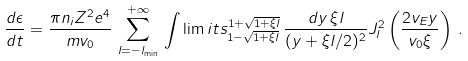Convert formula to latex. <formula><loc_0><loc_0><loc_500><loc_500>\frac { d \epsilon } { d t } = \frac { \pi n _ { i } Z ^ { 2 } e ^ { 4 } } { m v _ { 0 } } \, \sum _ { l = - l _ { \min } } ^ { + \infty } \, \int \lim i t s _ { 1 - \sqrt { 1 + \xi l } } ^ { 1 + \sqrt { 1 + \xi l } } \, \frac { d y \, \xi l } { ( y + \xi l / 2 ) ^ { 2 } } J _ { l } ^ { 2 } \left ( \frac { 2 v _ { E } y } { v _ { 0 } \xi } \right ) \, .</formula> 